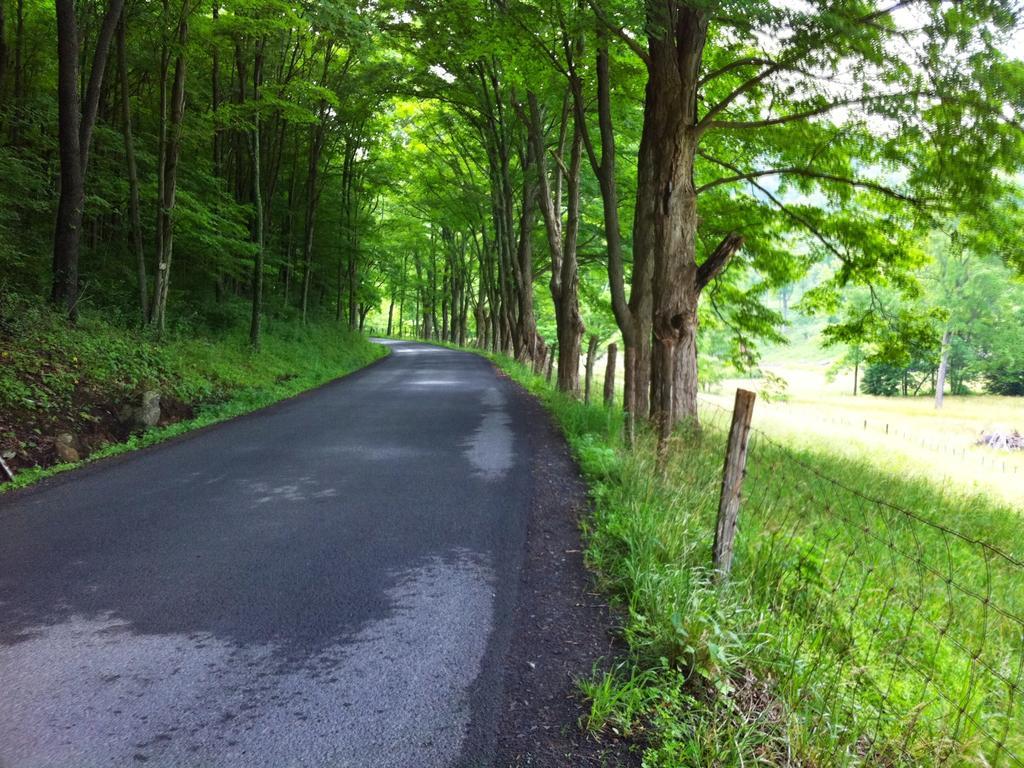Could you give a brief overview of what you see in this image? In this image we can see the road, wired fence, grass and many trees on either side. 